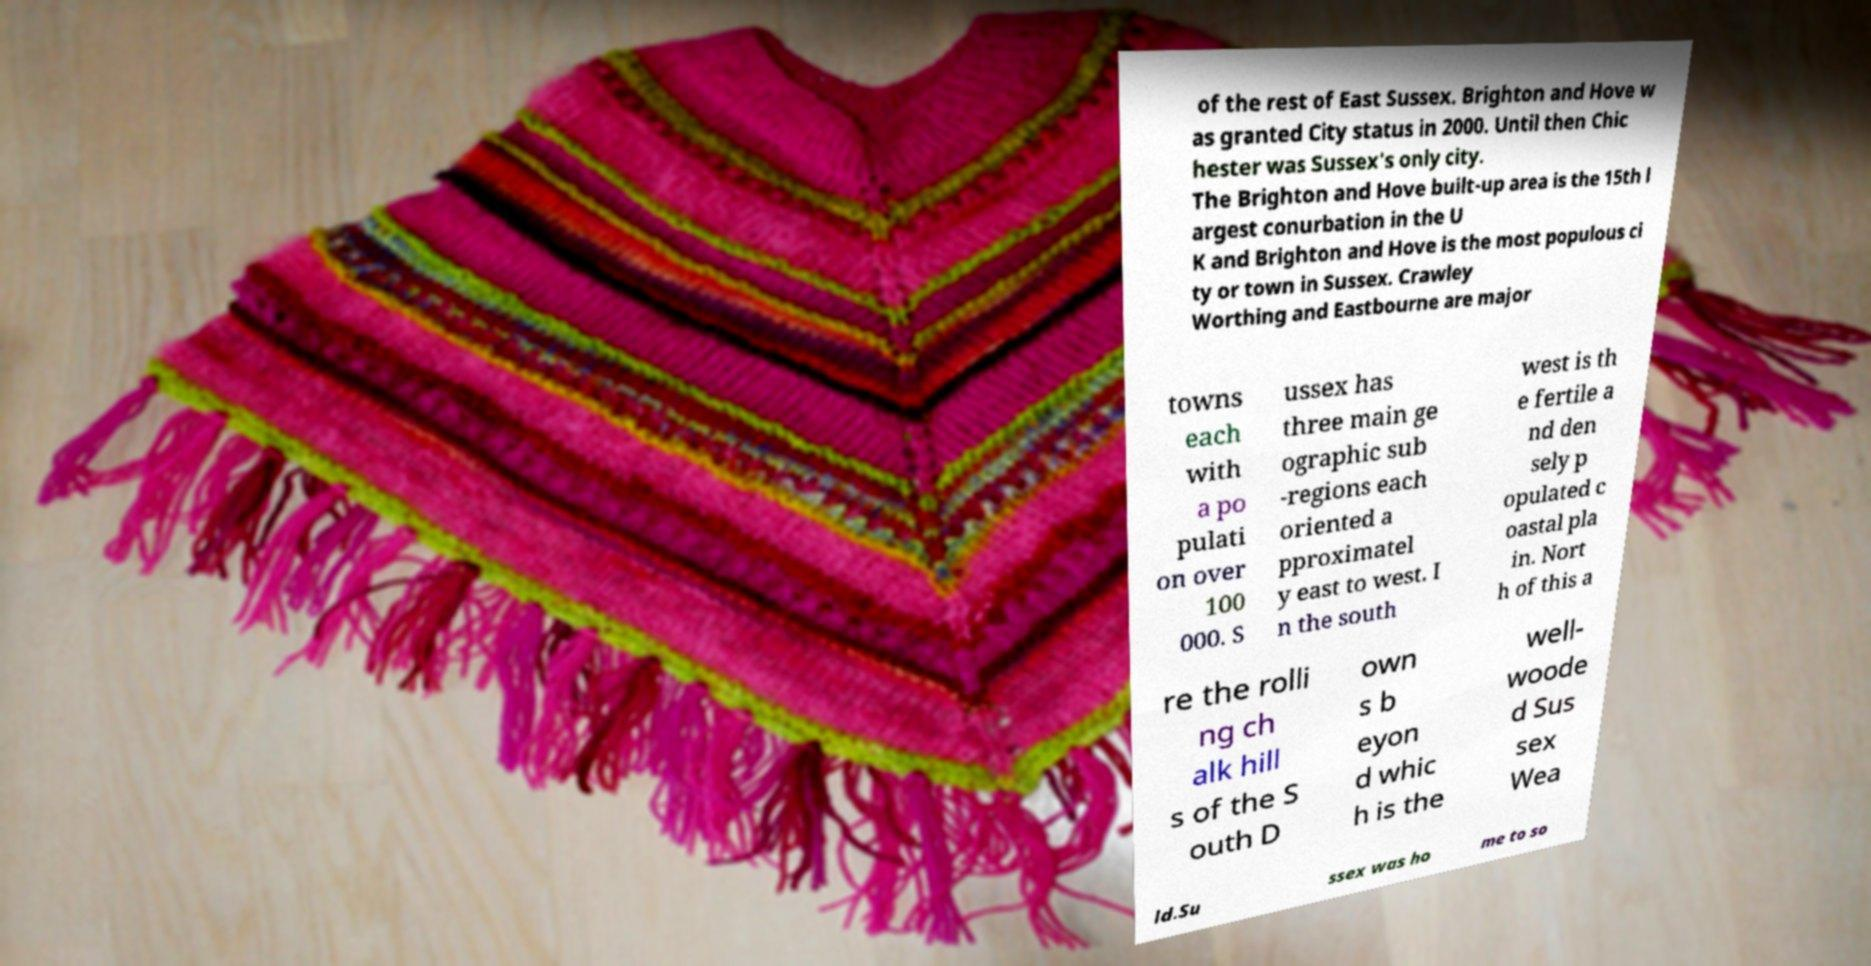Could you extract and type out the text from this image? of the rest of East Sussex. Brighton and Hove w as granted City status in 2000. Until then Chic hester was Sussex's only city. The Brighton and Hove built-up area is the 15th l argest conurbation in the U K and Brighton and Hove is the most populous ci ty or town in Sussex. Crawley Worthing and Eastbourne are major towns each with a po pulati on over 100 000. S ussex has three main ge ographic sub -regions each oriented a pproximatel y east to west. I n the south west is th e fertile a nd den sely p opulated c oastal pla in. Nort h of this a re the rolli ng ch alk hill s of the S outh D own s b eyon d whic h is the well- woode d Sus sex Wea ld.Su ssex was ho me to so 